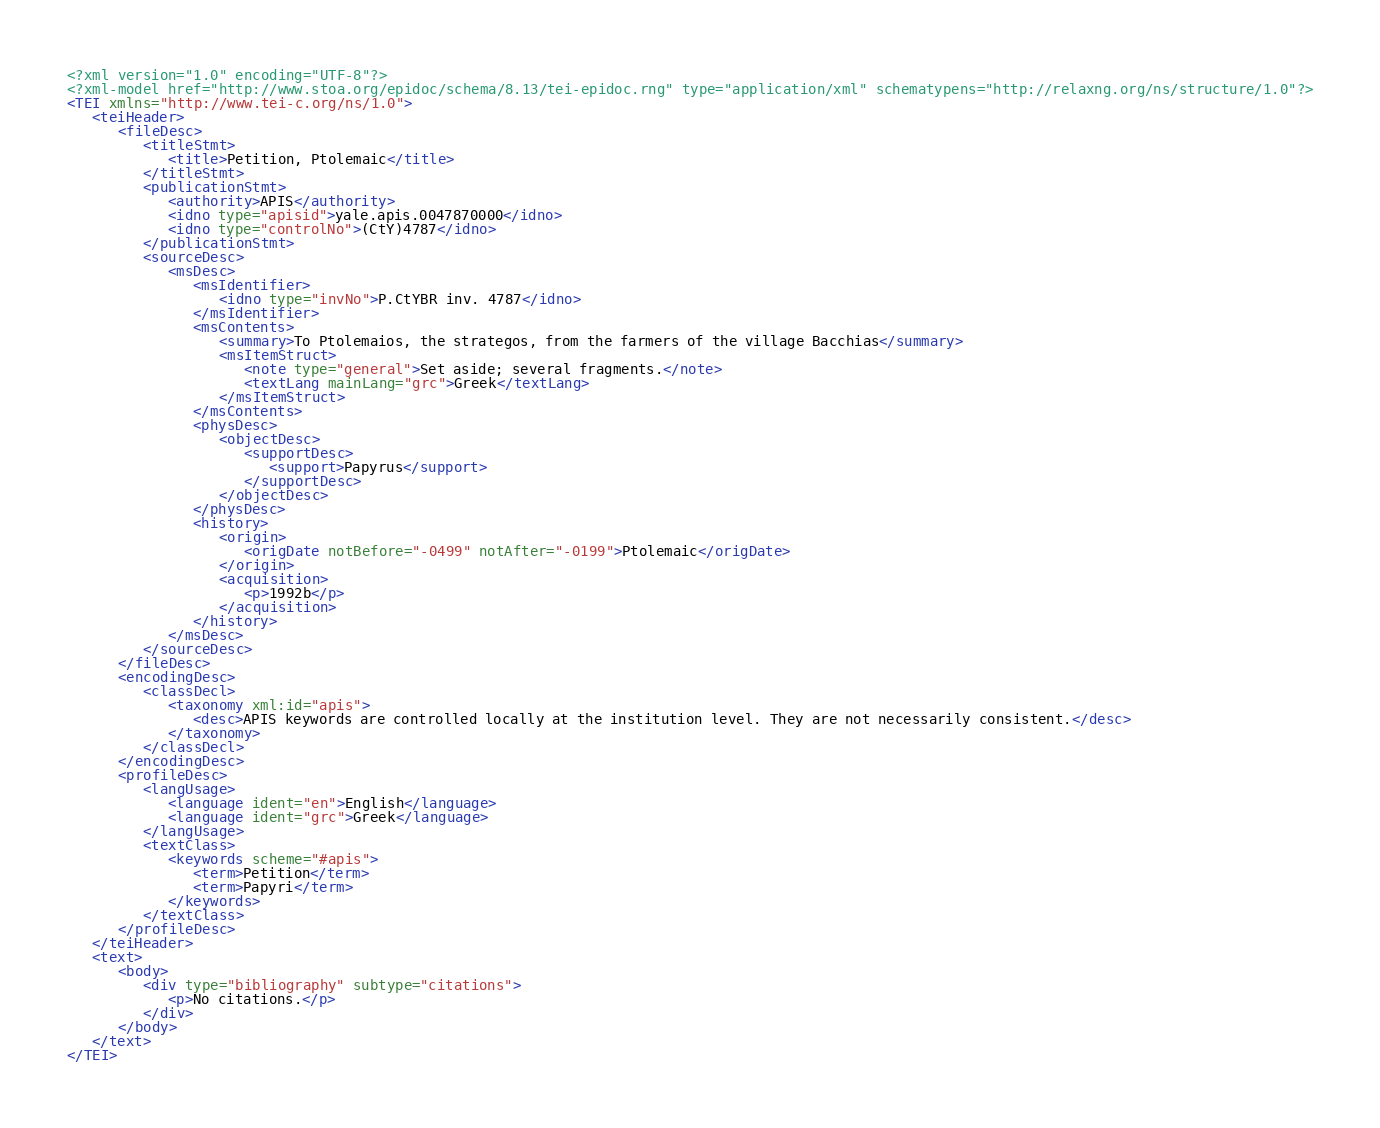Convert code to text. <code><loc_0><loc_0><loc_500><loc_500><_XML_><?xml version="1.0" encoding="UTF-8"?>
<?xml-model href="http://www.stoa.org/epidoc/schema/8.13/tei-epidoc.rng" type="application/xml" schematypens="http://relaxng.org/ns/structure/1.0"?>
<TEI xmlns="http://www.tei-c.org/ns/1.0">
   <teiHeader>
      <fileDesc>
         <titleStmt>
            <title>Petition, Ptolemaic</title>
         </titleStmt>
         <publicationStmt>
            <authority>APIS</authority>
            <idno type="apisid">yale.apis.0047870000</idno>
            <idno type="controlNo">(CtY)4787</idno>
         </publicationStmt>
         <sourceDesc>
            <msDesc>
               <msIdentifier>
                  <idno type="invNo">P.CtYBR inv. 4787</idno>
               </msIdentifier>
               <msContents>
                  <summary>To Ptolemaios, the strategos, from the farmers of the village Bacchias</summary>
                  <msItemStruct>
                     <note type="general">Set aside; several fragments.</note>
                     <textLang mainLang="grc">Greek</textLang>
                  </msItemStruct>
               </msContents>
               <physDesc>
                  <objectDesc>
                     <supportDesc>
                        <support>Papyrus</support>
                     </supportDesc>
                  </objectDesc>
               </physDesc>
               <history>
                  <origin>
                     <origDate notBefore="-0499" notAfter="-0199">Ptolemaic</origDate>
                  </origin>
                  <acquisition>
                     <p>1992b</p>
                  </acquisition>
               </history>
            </msDesc>
         </sourceDesc>
      </fileDesc>
      <encodingDesc>
         <classDecl>
            <taxonomy xml:id="apis">
               <desc>APIS keywords are controlled locally at the institution level. They are not necessarily consistent.</desc>
            </taxonomy>
         </classDecl>
      </encodingDesc>
      <profileDesc>
         <langUsage>
            <language ident="en">English</language>
            <language ident="grc">Greek</language>
         </langUsage>
         <textClass>
            <keywords scheme="#apis">
               <term>Petition</term>
               <term>Papyri</term>
            </keywords>
         </textClass>
      </profileDesc>
   </teiHeader>
   <text>
      <body>
         <div type="bibliography" subtype="citations">
            <p>No citations.</p>
         </div>
      </body>
   </text>
</TEI>
</code> 